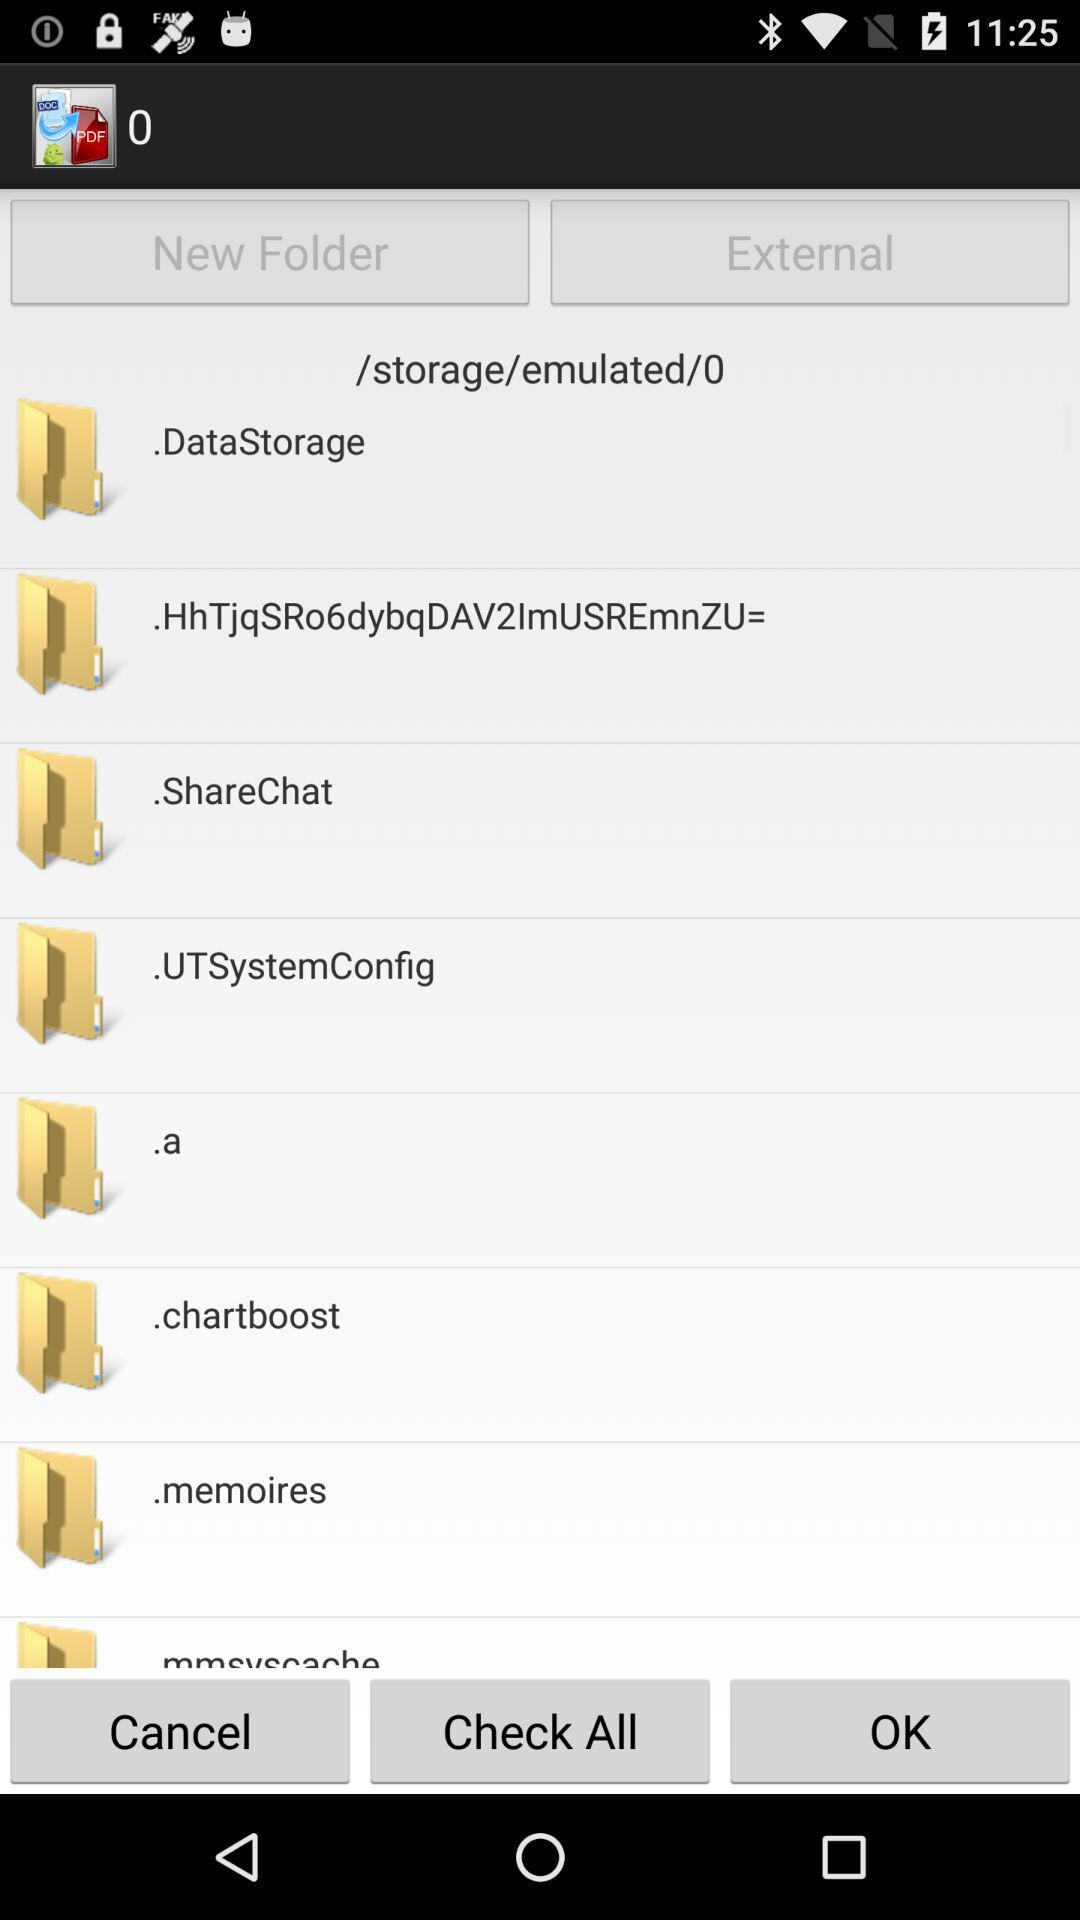What is the total number of items chosen?
When the provided information is insufficient, respond with <no answer>. <no answer> 